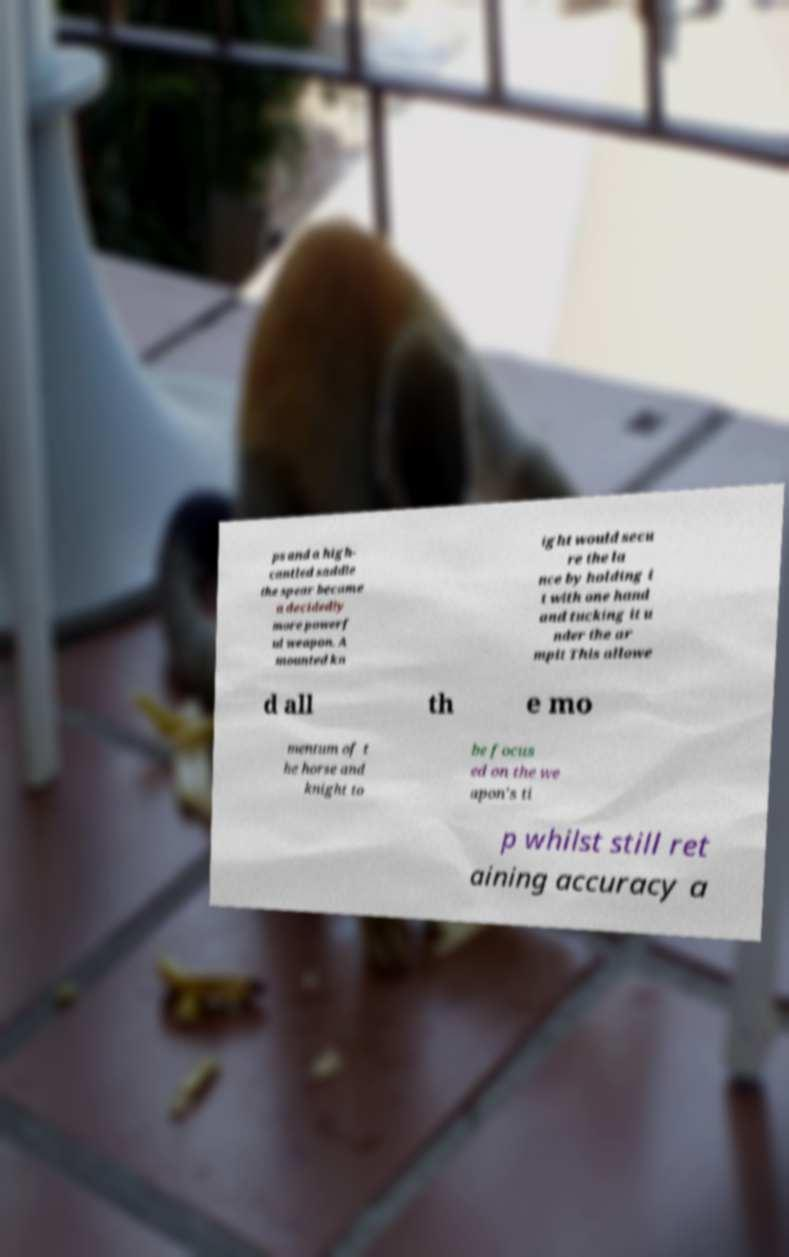I need the written content from this picture converted into text. Can you do that? ps and a high- cantled saddle the spear became a decidedly more powerf ul weapon. A mounted kn ight would secu re the la nce by holding i t with one hand and tucking it u nder the ar mpit This allowe d all th e mo mentum of t he horse and knight to be focus ed on the we apon's ti p whilst still ret aining accuracy a 